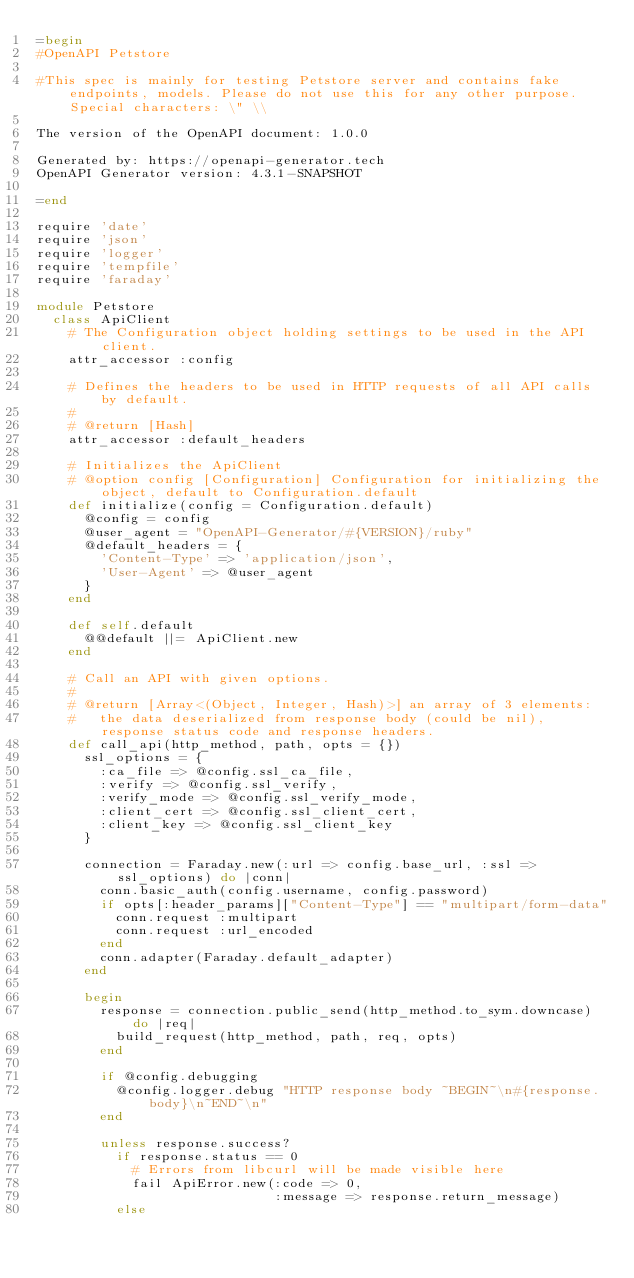<code> <loc_0><loc_0><loc_500><loc_500><_Ruby_>=begin
#OpenAPI Petstore

#This spec is mainly for testing Petstore server and contains fake endpoints, models. Please do not use this for any other purpose. Special characters: \" \\

The version of the OpenAPI document: 1.0.0

Generated by: https://openapi-generator.tech
OpenAPI Generator version: 4.3.1-SNAPSHOT

=end

require 'date'
require 'json'
require 'logger'
require 'tempfile'
require 'faraday'

module Petstore
  class ApiClient
    # The Configuration object holding settings to be used in the API client.
    attr_accessor :config

    # Defines the headers to be used in HTTP requests of all API calls by default.
    #
    # @return [Hash]
    attr_accessor :default_headers

    # Initializes the ApiClient
    # @option config [Configuration] Configuration for initializing the object, default to Configuration.default
    def initialize(config = Configuration.default)
      @config = config
      @user_agent = "OpenAPI-Generator/#{VERSION}/ruby"
      @default_headers = {
        'Content-Type' => 'application/json',
        'User-Agent' => @user_agent
      }
    end

    def self.default
      @@default ||= ApiClient.new
    end

    # Call an API with given options.
    #
    # @return [Array<(Object, Integer, Hash)>] an array of 3 elements:
    #   the data deserialized from response body (could be nil), response status code and response headers.
    def call_api(http_method, path, opts = {})
      ssl_options = {
        :ca_file => @config.ssl_ca_file,
        :verify => @config.ssl_verify,
        :verify_mode => @config.ssl_verify_mode,
        :client_cert => @config.ssl_client_cert,
        :client_key => @config.ssl_client_key
      }

      connection = Faraday.new(:url => config.base_url, :ssl => ssl_options) do |conn|
        conn.basic_auth(config.username, config.password)
        if opts[:header_params]["Content-Type"] == "multipart/form-data"
          conn.request :multipart
          conn.request :url_encoded
        end
        conn.adapter(Faraday.default_adapter)
      end

      begin
        response = connection.public_send(http_method.to_sym.downcase) do |req|
          build_request(http_method, path, req, opts)
        end

        if @config.debugging
          @config.logger.debug "HTTP response body ~BEGIN~\n#{response.body}\n~END~\n"
        end

        unless response.success?
          if response.status == 0
            # Errors from libcurl will be made visible here
            fail ApiError.new(:code => 0,
                              :message => response.return_message)
          else</code> 